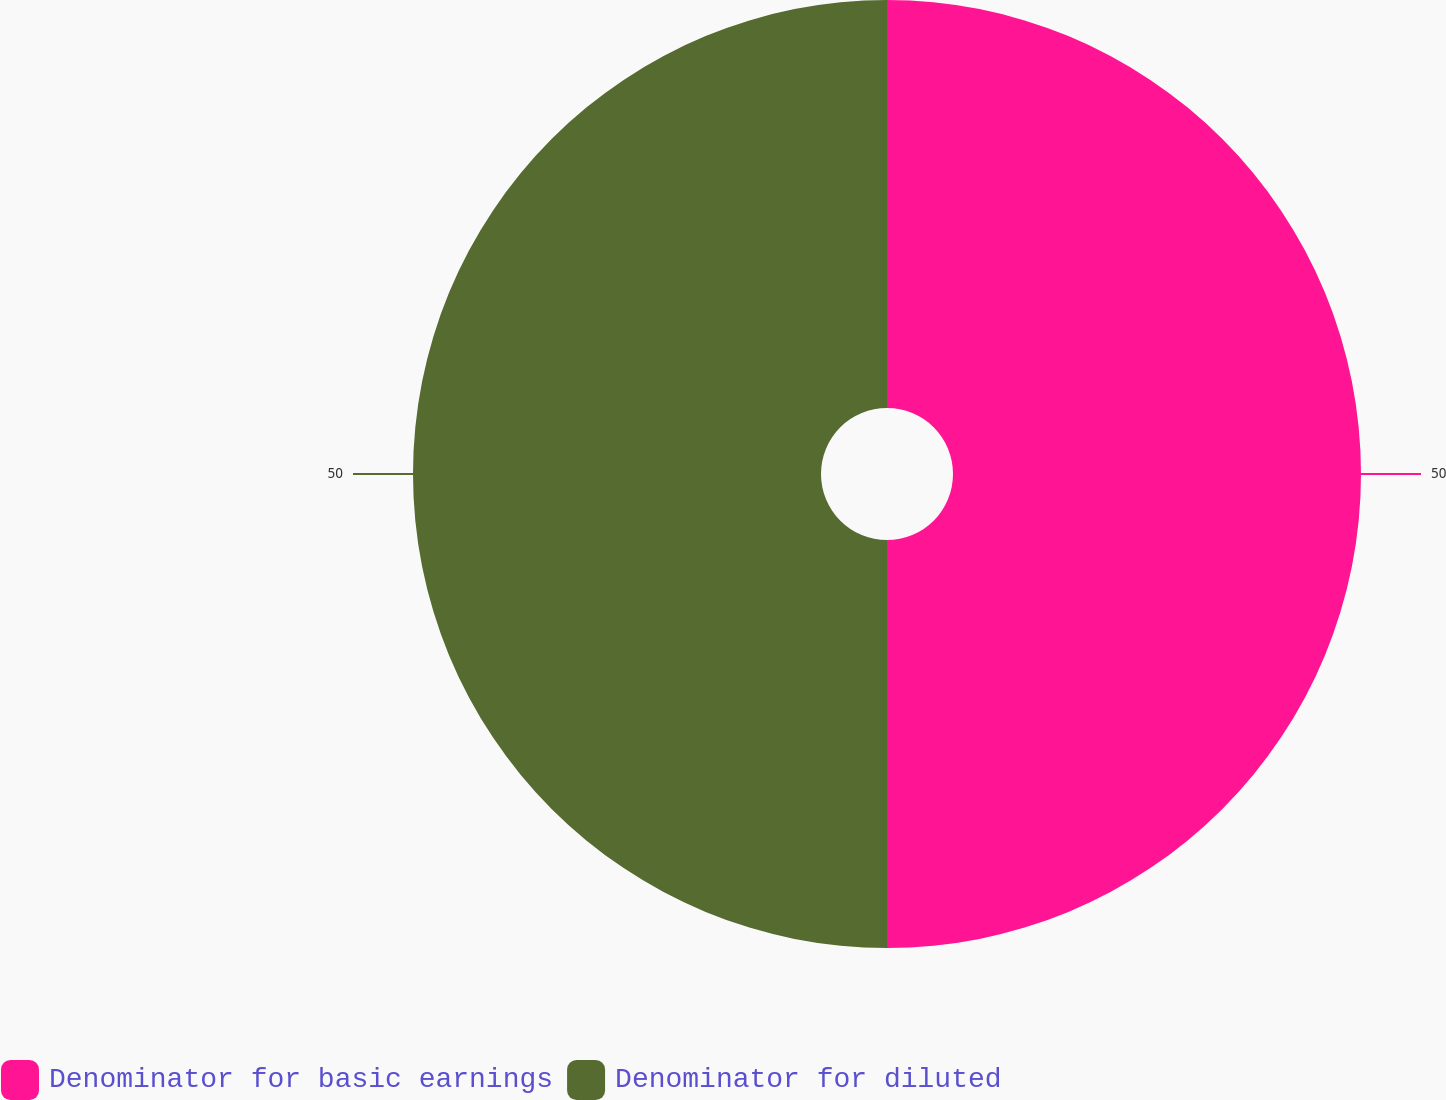<chart> <loc_0><loc_0><loc_500><loc_500><pie_chart><fcel>Denominator for basic earnings<fcel>Denominator for diluted<nl><fcel>50.0%<fcel>50.0%<nl></chart> 